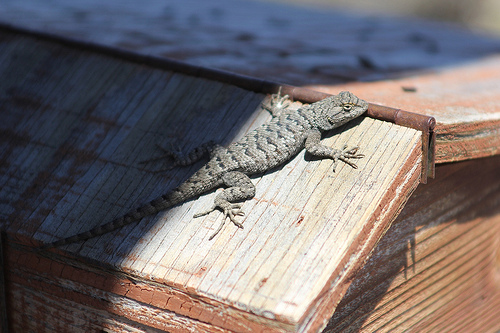<image>
Is the lizard on the wood? Yes. Looking at the image, I can see the lizard is positioned on top of the wood, with the wood providing support. 